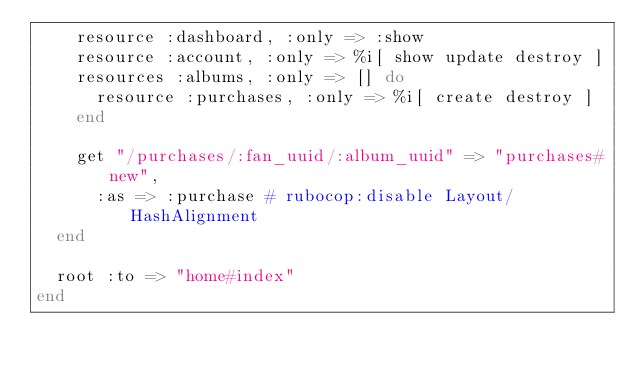Convert code to text. <code><loc_0><loc_0><loc_500><loc_500><_Ruby_>    resource :dashboard, :only => :show
    resource :account, :only => %i[ show update destroy ]
    resources :albums, :only => [] do
      resource :purchases, :only => %i[ create destroy ]
    end

    get "/purchases/:fan_uuid/:album_uuid" => "purchases#new",
      :as => :purchase # rubocop:disable Layout/HashAlignment
  end

  root :to => "home#index"
end
</code> 